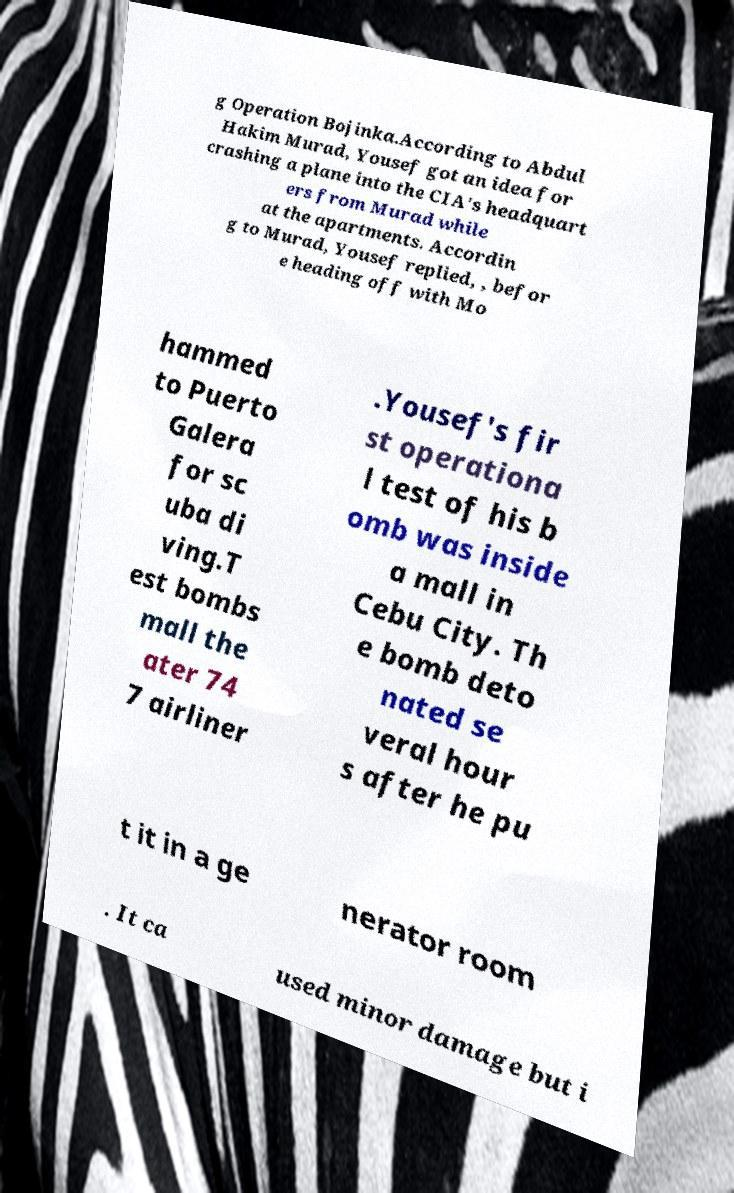Could you extract and type out the text from this image? g Operation Bojinka.According to Abdul Hakim Murad, Yousef got an idea for crashing a plane into the CIA's headquart ers from Murad while at the apartments. Accordin g to Murad, Yousef replied, , befor e heading off with Mo hammed to Puerto Galera for sc uba di ving.T est bombs mall the ater 74 7 airliner .Yousef's fir st operationa l test of his b omb was inside a mall in Cebu City. Th e bomb deto nated se veral hour s after he pu t it in a ge nerator room . It ca used minor damage but i 